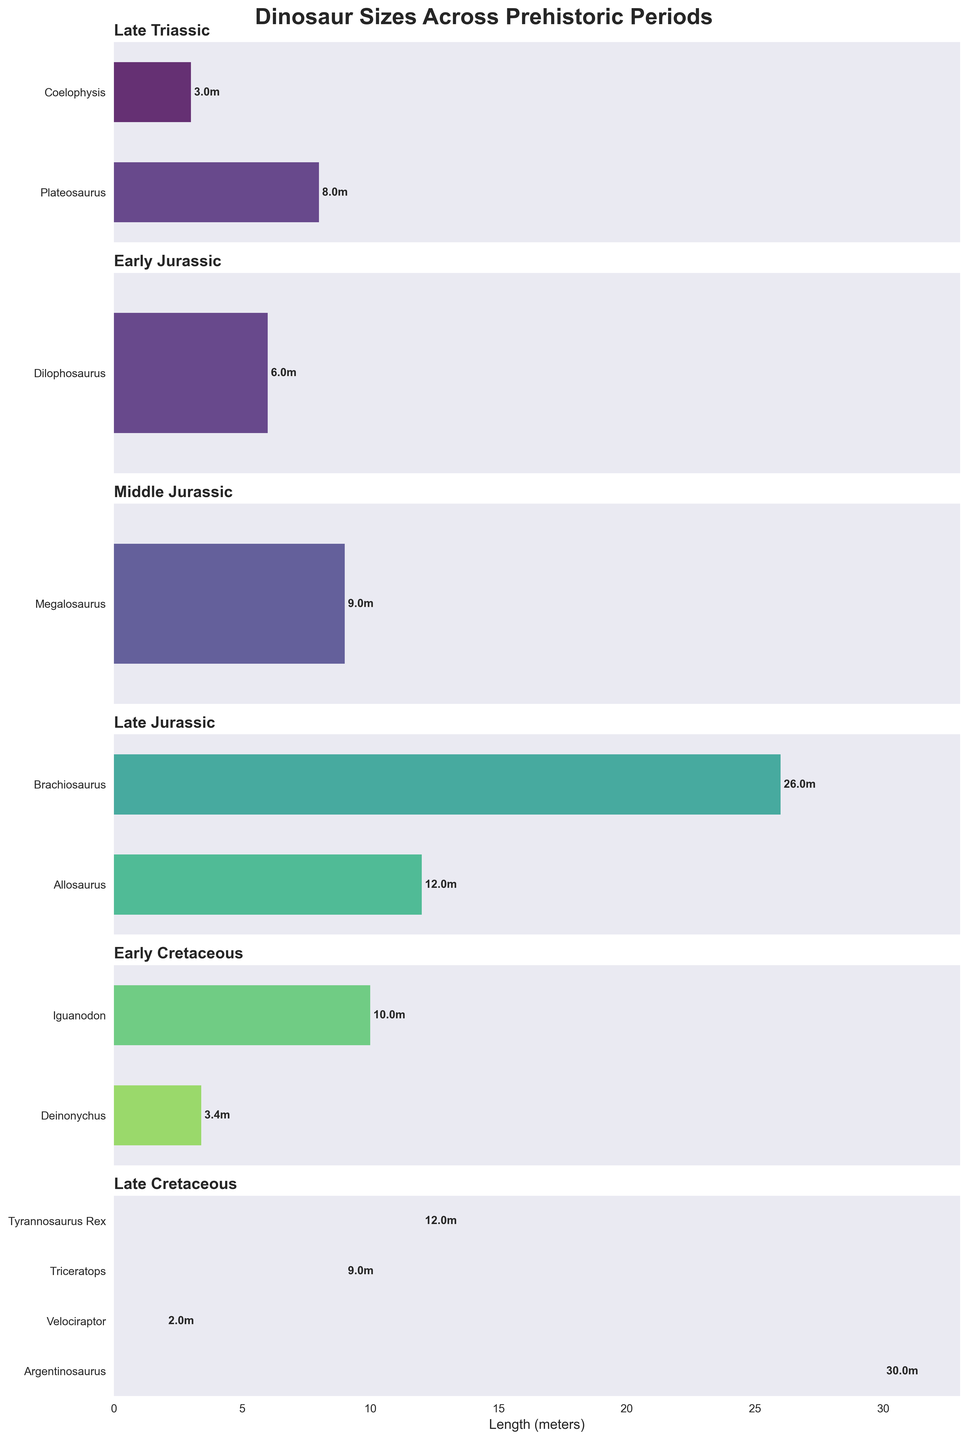What is the title of the figure? The title is located at the top of the figure, prominently displayed in bold font. It gives a summary of what the figure is about.
Answer: Dinosaur Sizes Across Prehistoric Periods How many dinosaurs are represented in the Late Cretaceous period? Count the number of bars in the subplot labeled "Late Cretaceous." Each bar represents a different dinosaur.
Answer: 4 Which dinosaur in the Late Jurassic period is the longest, and what is its length? Identify the longest bar in the subplot labeled "Late Jurassic." The length is noted next to the bar.
Answer: Brachiosaurus, 26 meters Which period has the largest number of dinosaur species represented, and how many are there? Count the bars for each period and identify which subplot has the most bars.
Answer: Late Cretaceous, 4 species Compare the lengths of Plateosaurus and Iguanodon. Which one is longer and by how much? Look at the subplots for "Late Triassic" and "Early Cretaceous" and compare the lengths of Plateosaurus and Iguanodon. Subtract the smaller length from the larger length.
Answer: Plateosaurus is longer by 2 meters (8m - 6m) What is the total length of all dinosaurs in the Early Cretaceous period? Sum up the lengths of Deinonychus and Iguanodon from the "Early Cretaceous" subplot.
Answer: 13.4 meters (10 + 3.4) Which dinosaur has the shortest length in the entire figure, and in which period is it found? Scan all subplots and identify the shortest bar.
Answer: Velociraptor, Late Cretaceous Rank the periods by their longest dinosaur from longest to shortest. List the longest dinosaur in each period and order them by length.
Answer: Late Cretaceous > Late Jurassic > Middle Jurassic > Early Cretaceous > Early Jurassic > Late Triassic What is the difference in length between the longest dinosaur in the Late Triassic and the shortest dinosaur in the Late Cretaceous? Identify the longest dinosaur in the "Late Triassic" and the shortest in the "Late Cretaceous." Calculate the difference.
Answer: 6 meters (8 - 2) Which dinosaurs have the same length, and what is that length? Look for bars in different periods with the same length marked next to them.
Answer: Brachiosaurus, Triceratops, and Megalosaurus, all 9 meters 